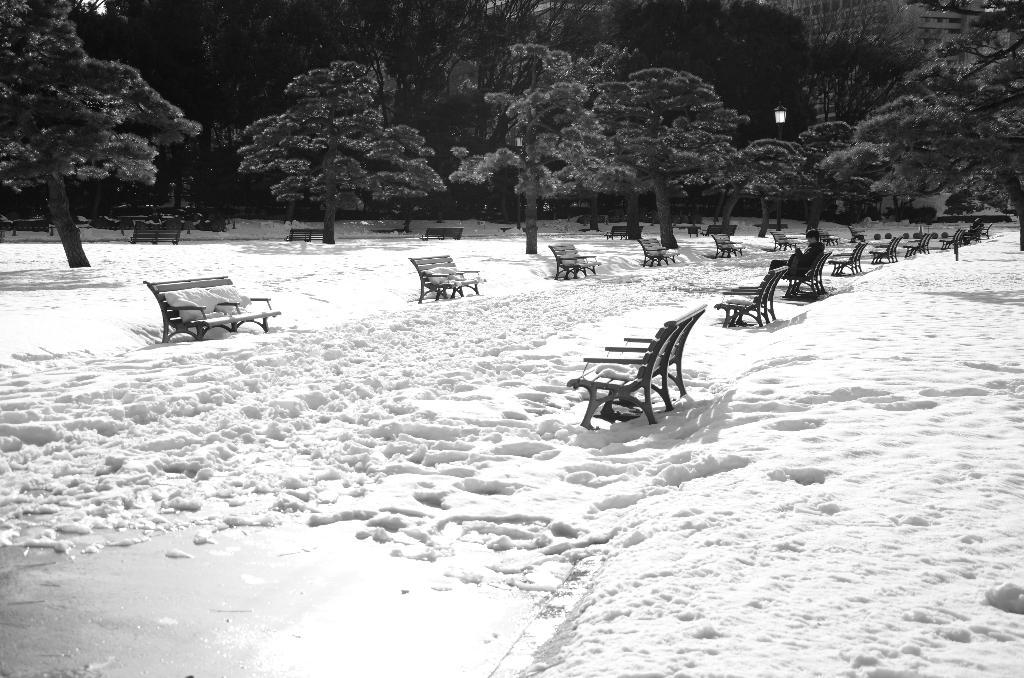What is the color scheme of the image? The image is black and white. What type of natural elements can be seen in the image? There are trees in the image. What type of man-made structures are present in the image? There are benches and a building in the image. What is the weather like in the image? It is snowing in the image. Can you describe the lighting in the image? There is a light in the image. What type of horn can be heard in the image? There is no horn present in the image, and therefore no sound can be heard. How many ears are visible on the trees in the image? Trees do not have ears, so this question cannot be answered based on the image. 